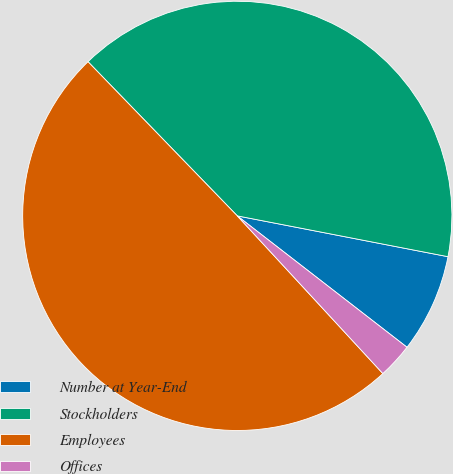<chart> <loc_0><loc_0><loc_500><loc_500><pie_chart><fcel>Number at Year-End<fcel>Stockholders<fcel>Employees<fcel>Offices<nl><fcel>7.44%<fcel>40.29%<fcel>49.62%<fcel>2.65%<nl></chart> 